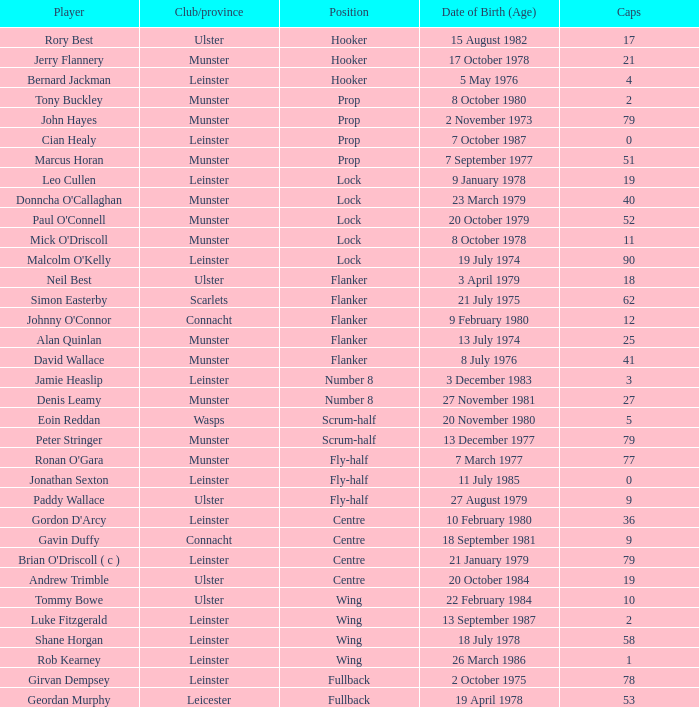What is the total of Caps when player born 13 December 1977? 79.0. 